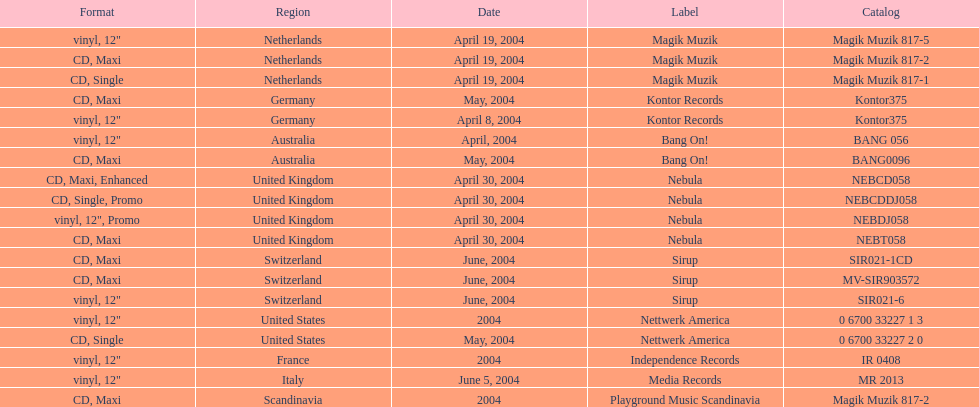Could you parse the entire table as a dict? {'header': ['Format', 'Region', 'Date', 'Label', 'Catalog'], 'rows': [['vinyl, 12"', 'Netherlands', 'April 19, 2004', 'Magik Muzik', 'Magik Muzik 817-5'], ['CD, Maxi', 'Netherlands', 'April 19, 2004', 'Magik Muzik', 'Magik Muzik 817-2'], ['CD, Single', 'Netherlands', 'April 19, 2004', 'Magik Muzik', 'Magik Muzik 817-1'], ['CD, Maxi', 'Germany', 'May, 2004', 'Kontor Records', 'Kontor375'], ['vinyl, 12"', 'Germany', 'April 8, 2004', 'Kontor Records', 'Kontor375'], ['vinyl, 12"', 'Australia', 'April, 2004', 'Bang On!', 'BANG 056'], ['CD, Maxi', 'Australia', 'May, 2004', 'Bang On!', 'BANG0096'], ['CD, Maxi, Enhanced', 'United Kingdom', 'April 30, 2004', 'Nebula', 'NEBCD058'], ['CD, Single, Promo', 'United Kingdom', 'April 30, 2004', 'Nebula', 'NEBCDDJ058'], ['vinyl, 12", Promo', 'United Kingdom', 'April 30, 2004', 'Nebula', 'NEBDJ058'], ['CD, Maxi', 'United Kingdom', 'April 30, 2004', 'Nebula', 'NEBT058'], ['CD, Maxi', 'Switzerland', 'June, 2004', 'Sirup', 'SIR021-1CD'], ['CD, Maxi', 'Switzerland', 'June, 2004', 'Sirup', 'MV-SIR903572'], ['vinyl, 12"', 'Switzerland', 'June, 2004', 'Sirup', 'SIR021-6'], ['vinyl, 12"', 'United States', '2004', 'Nettwerk America', '0 6700 33227 1 3'], ['CD, Single', 'United States', 'May, 2004', 'Nettwerk America', '0 6700 33227 2 0'], ['vinyl, 12"', 'France', '2004', 'Independence Records', 'IR 0408'], ['vinyl, 12"', 'Italy', 'June 5, 2004', 'Media Records', 'MR 2013'], ['CD, Maxi', 'Scandinavia', '2004', 'Playground Music Scandinavia', 'Magik Muzik 817-2']]} How many catalogs were released? 19. 